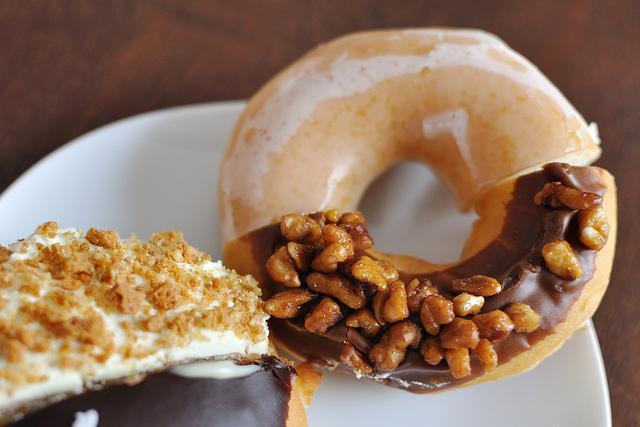How many donuts are in the picture?
Give a very brief answer. 3. How many sheep are walking?
Give a very brief answer. 0. 